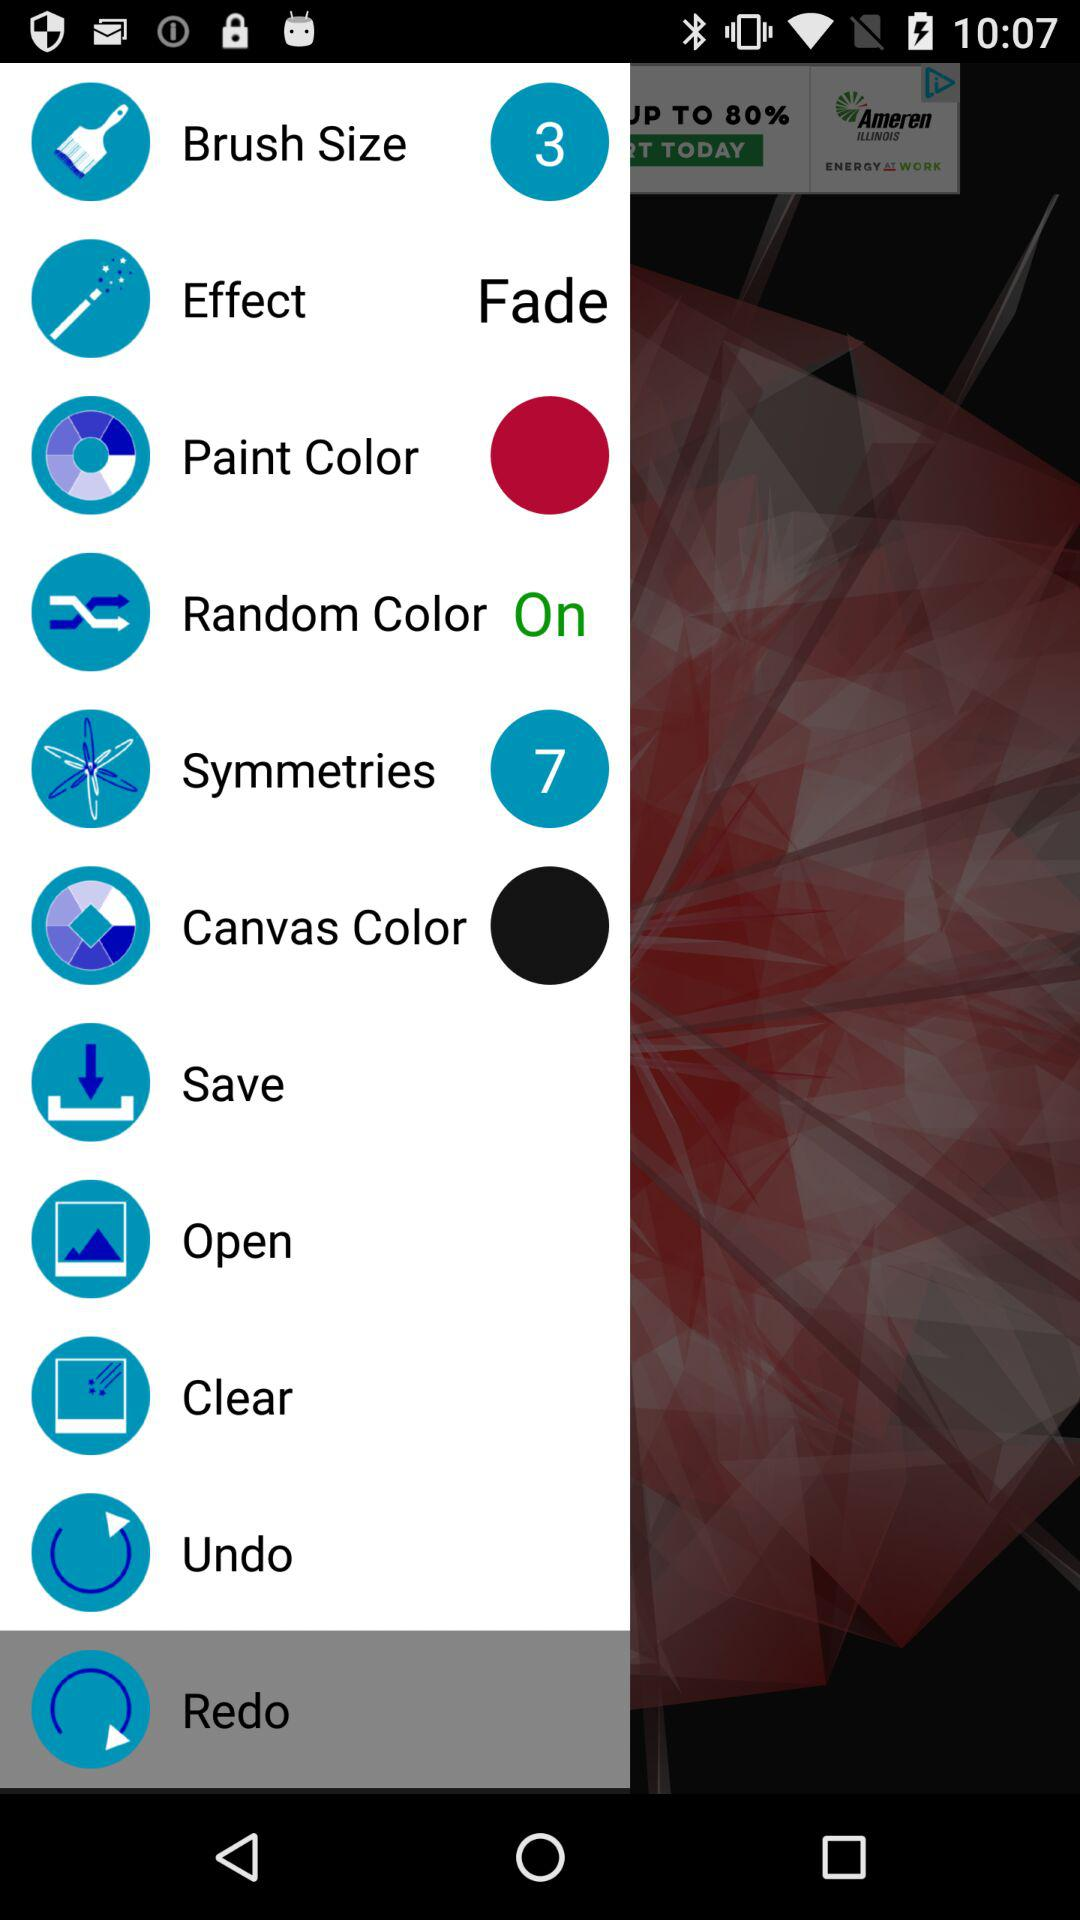What is the status of "Random Color"? The status of "Random Color" is "on". 